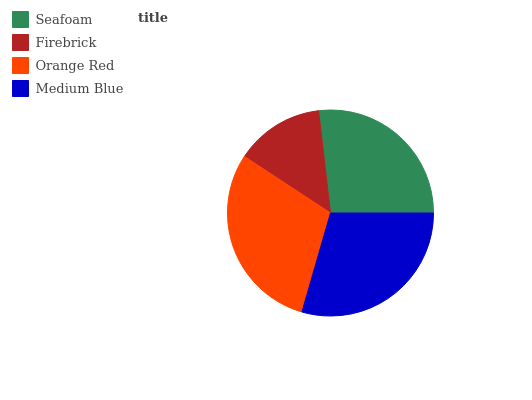Is Firebrick the minimum?
Answer yes or no. Yes. Is Orange Red the maximum?
Answer yes or no. Yes. Is Orange Red the minimum?
Answer yes or no. No. Is Firebrick the maximum?
Answer yes or no. No. Is Orange Red greater than Firebrick?
Answer yes or no. Yes. Is Firebrick less than Orange Red?
Answer yes or no. Yes. Is Firebrick greater than Orange Red?
Answer yes or no. No. Is Orange Red less than Firebrick?
Answer yes or no. No. Is Medium Blue the high median?
Answer yes or no. Yes. Is Seafoam the low median?
Answer yes or no. Yes. Is Firebrick the high median?
Answer yes or no. No. Is Medium Blue the low median?
Answer yes or no. No. 